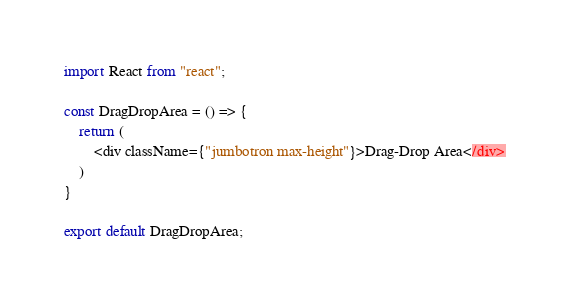Convert code to text. <code><loc_0><loc_0><loc_500><loc_500><_JavaScript_>import React from "react";

const DragDropArea = () => {
    return (
        <div className={"jumbotron max-height"}>Drag-Drop Area</div>
    )
}

export default DragDropArea;
</code> 